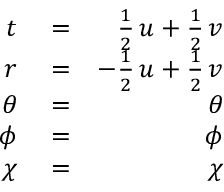Convert formula to latex. <formula><loc_0><loc_0><loc_500><loc_500>\begin{array} { r l r } { t } & = } & { \frac { 1 } { 2 } \, u + \frac { 1 } { 2 } \, v } \\ { r } & = } & { - \frac { 1 } { 2 } \, u + \frac { 1 } { 2 } \, v } \\ { \theta } & = } & { \theta } \\ { \phi } & = } & { \phi } \\ { \chi } & = } & { \chi } \end{array}</formula> 